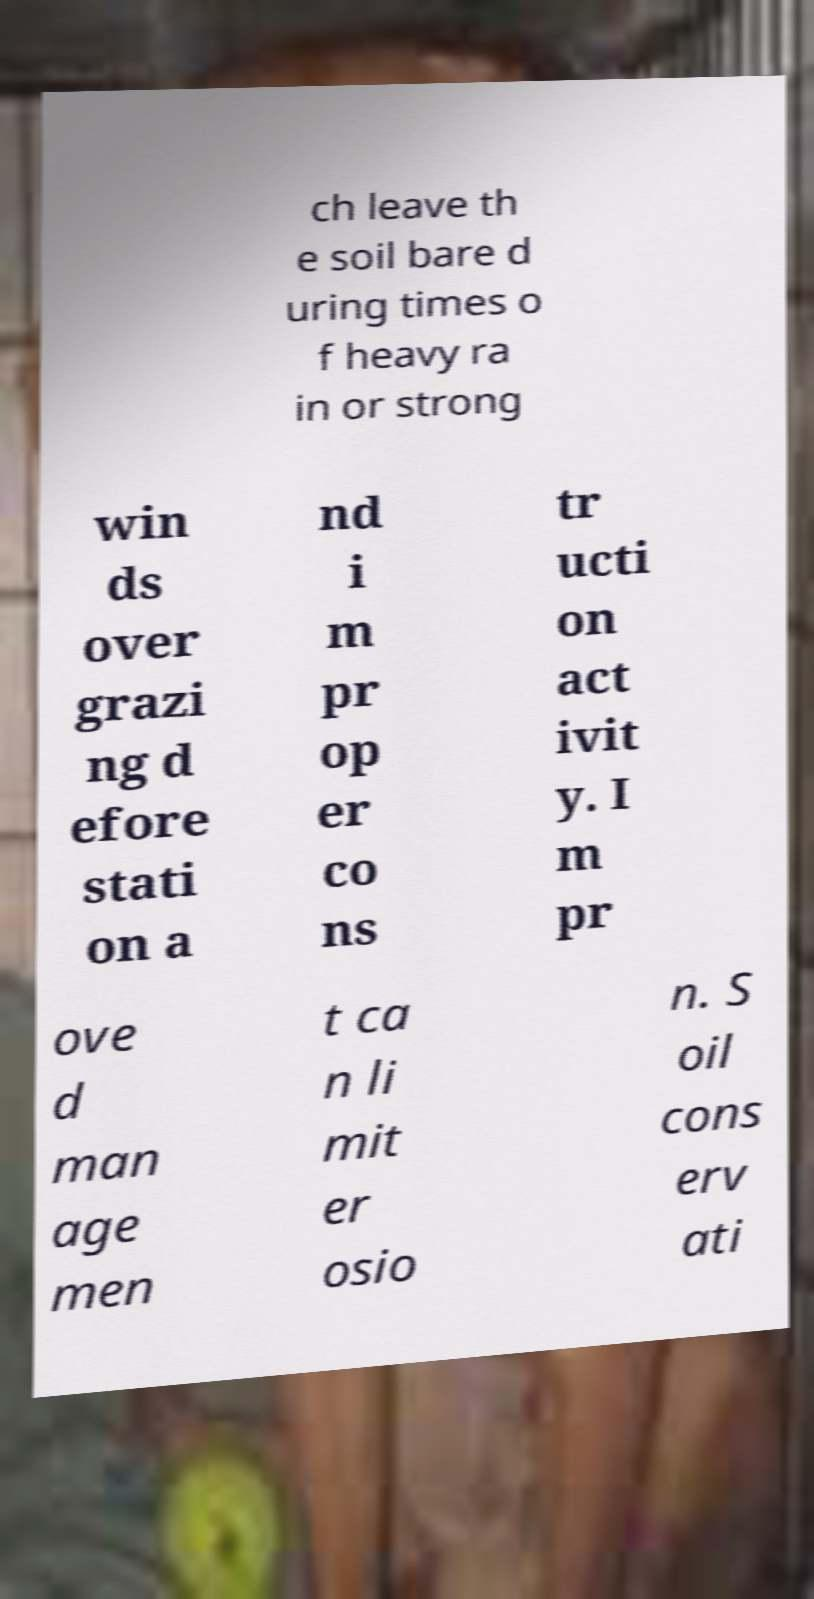I need the written content from this picture converted into text. Can you do that? ch leave th e soil bare d uring times o f heavy ra in or strong win ds over grazi ng d efore stati on a nd i m pr op er co ns tr ucti on act ivit y. I m pr ove d man age men t ca n li mit er osio n. S oil cons erv ati 